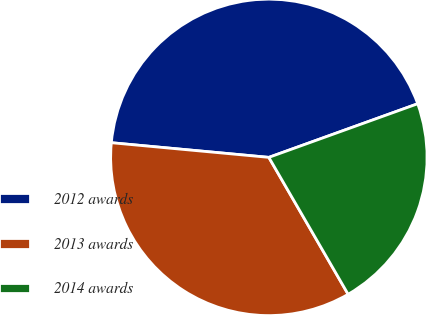Convert chart to OTSL. <chart><loc_0><loc_0><loc_500><loc_500><pie_chart><fcel>2012 awards<fcel>2013 awards<fcel>2014 awards<nl><fcel>43.02%<fcel>34.83%<fcel>22.15%<nl></chart> 